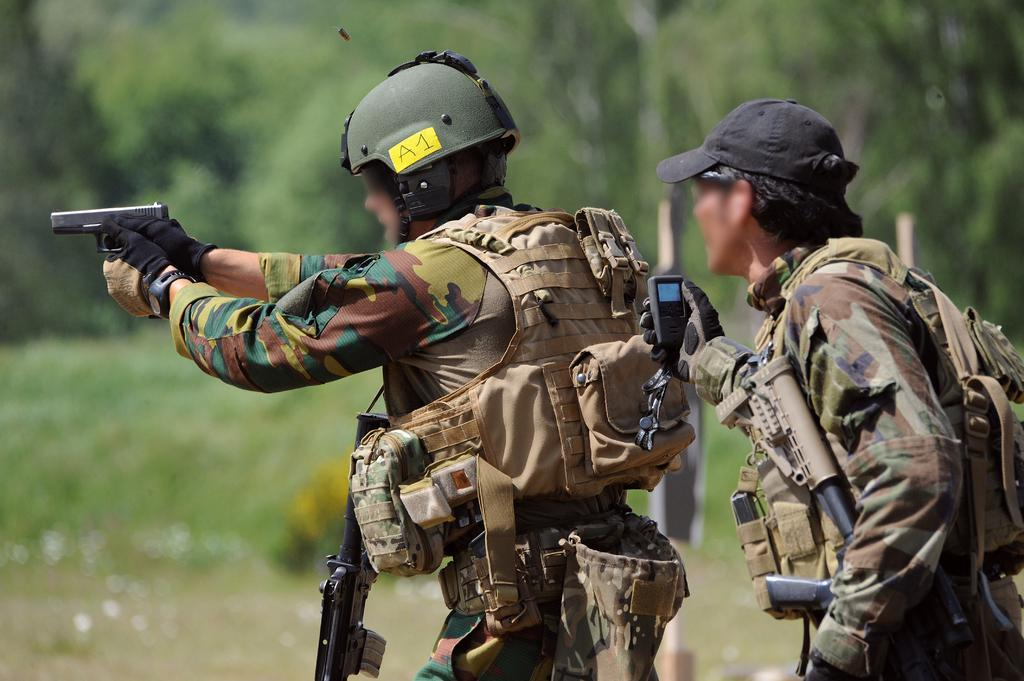How many army people are in the image? There are two army people in the image. What is one person holding in the image? One person is holding a gun. What is the other person holding in the image? The other person is holding a phone. What type of bulb is visible in the image? There is no bulb present in the image. How does the phone twist in the image? The phone does not twist in the image; it is held by one of the army people. 